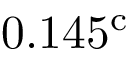Convert formula to latex. <formula><loc_0><loc_0><loc_500><loc_500>0 . 1 4 5 ^ { c }</formula> 